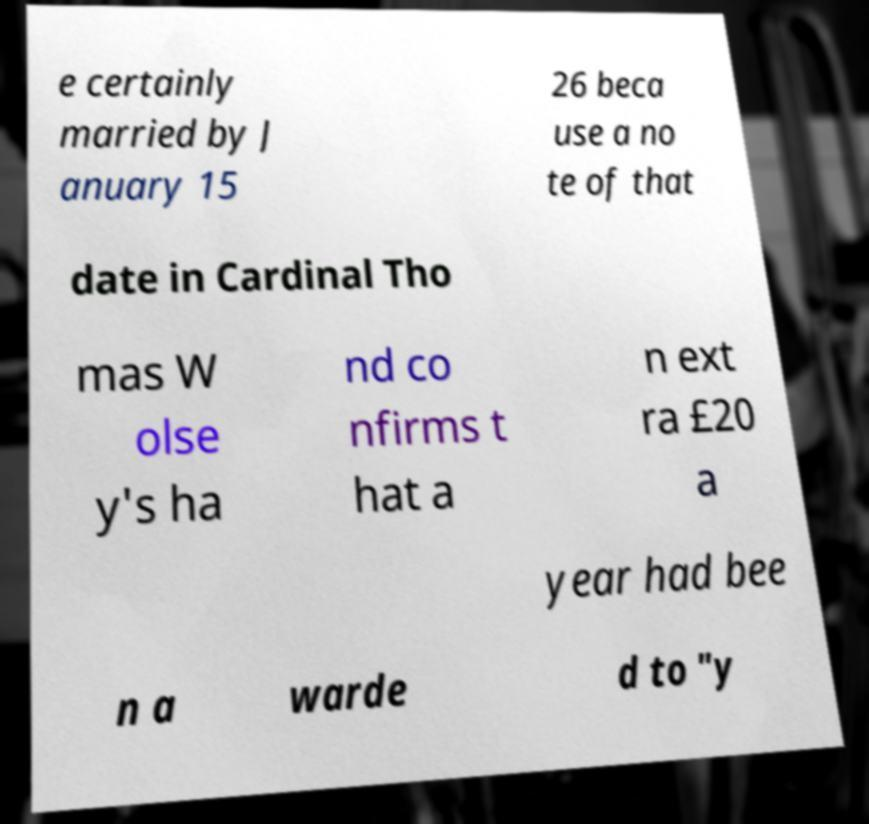For documentation purposes, I need the text within this image transcribed. Could you provide that? e certainly married by J anuary 15 26 beca use a no te of that date in Cardinal Tho mas W olse y's ha nd co nfirms t hat a n ext ra £20 a year had bee n a warde d to "y 